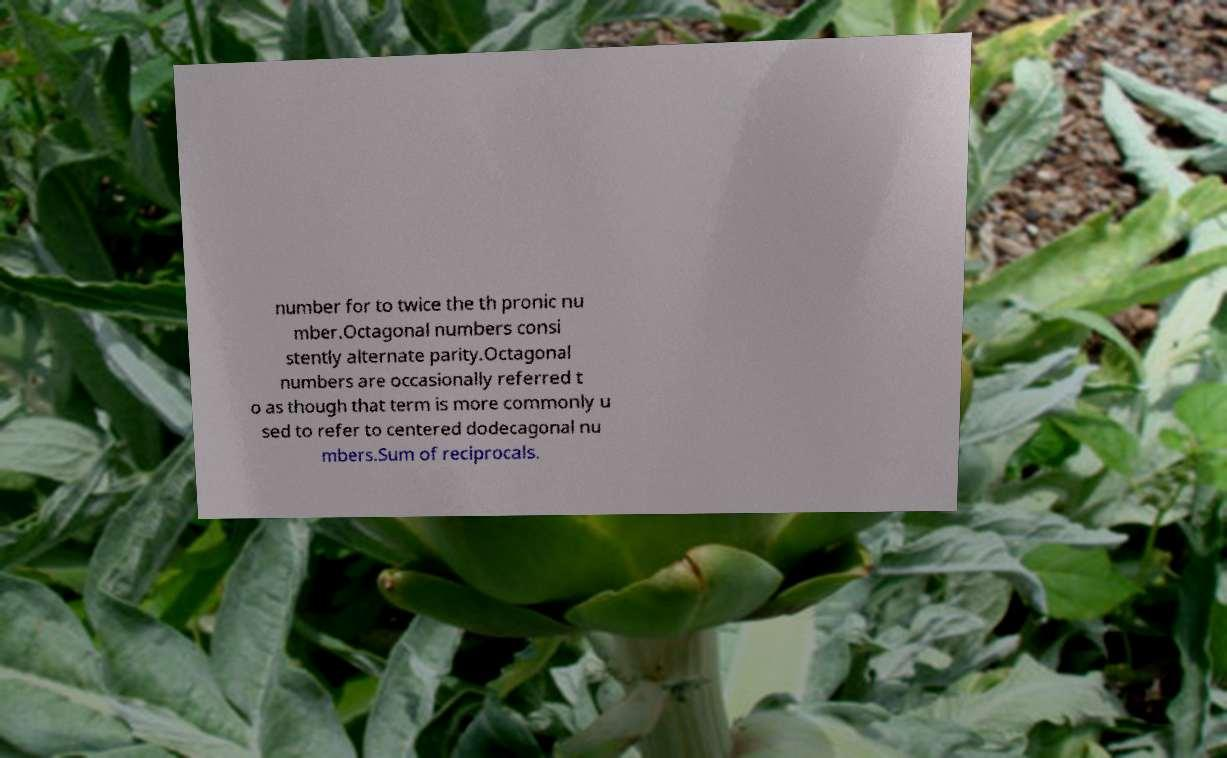What messages or text are displayed in this image? I need them in a readable, typed format. number for to twice the th pronic nu mber.Octagonal numbers consi stently alternate parity.Octagonal numbers are occasionally referred t o as though that term is more commonly u sed to refer to centered dodecagonal nu mbers.Sum of reciprocals. 